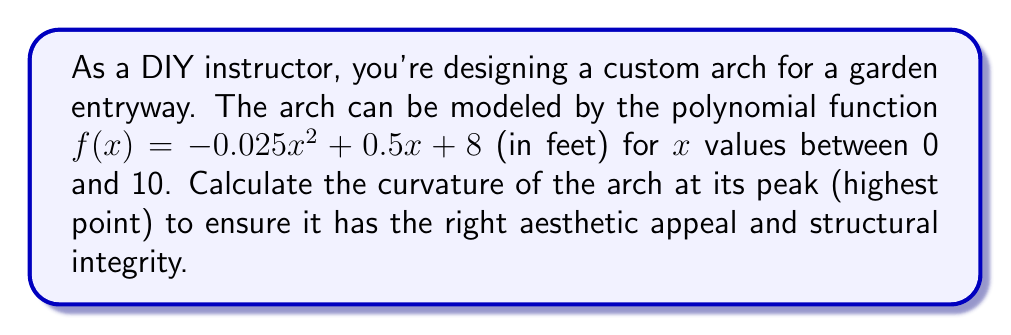Help me with this question. To solve this problem, we'll follow these steps:

1) First, we need to find the x-coordinate of the peak. The peak occurs where the first derivative is zero.

   $f'(x) = -0.05x + 0.5$
   
   Set this equal to zero:
   $-0.05x + 0.5 = 0$
   $-0.05x = -0.5$
   $x = 10$

2) The peak occurs at $x = 10$. Now we can calculate the curvature at this point.

3) The formula for curvature $K$ at any point on a function $y = f(x)$ is:

   $$K = \frac{|f''(x)|}{(1 + (f'(x))^2)^{3/2}}$$

4) We need to calculate $f'(x)$ and $f''(x)$:
   
   $f'(x) = -0.05x + 0.5$
   $f''(x) = -0.05$

5) At $x = 10$:
   
   $f'(10) = -0.05(10) + 0.5 = 0$
   $f''(10) = -0.05$

6) Now we can plug these into the curvature formula:

   $$K = \frac{|-0.05|}{(1 + (0)^2)^{3/2}} = \frac{0.05}{1} = 0.05$$

7) Therefore, the curvature at the peak of the arch is 0.05 ft^(-1).
Answer: The curvature of the arch at its peak is 0.05 ft^(-1). 